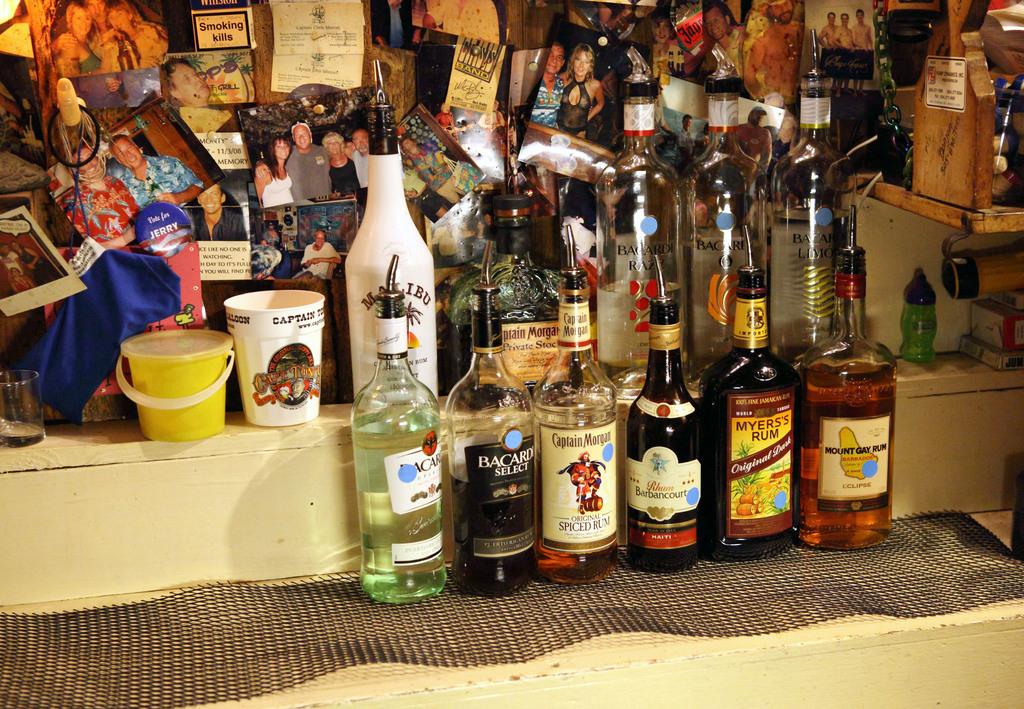Is there a bottle of bacardi on there?
Offer a very short reply. Yes. What is after meyer's?
Ensure brevity in your answer.  Rum. 